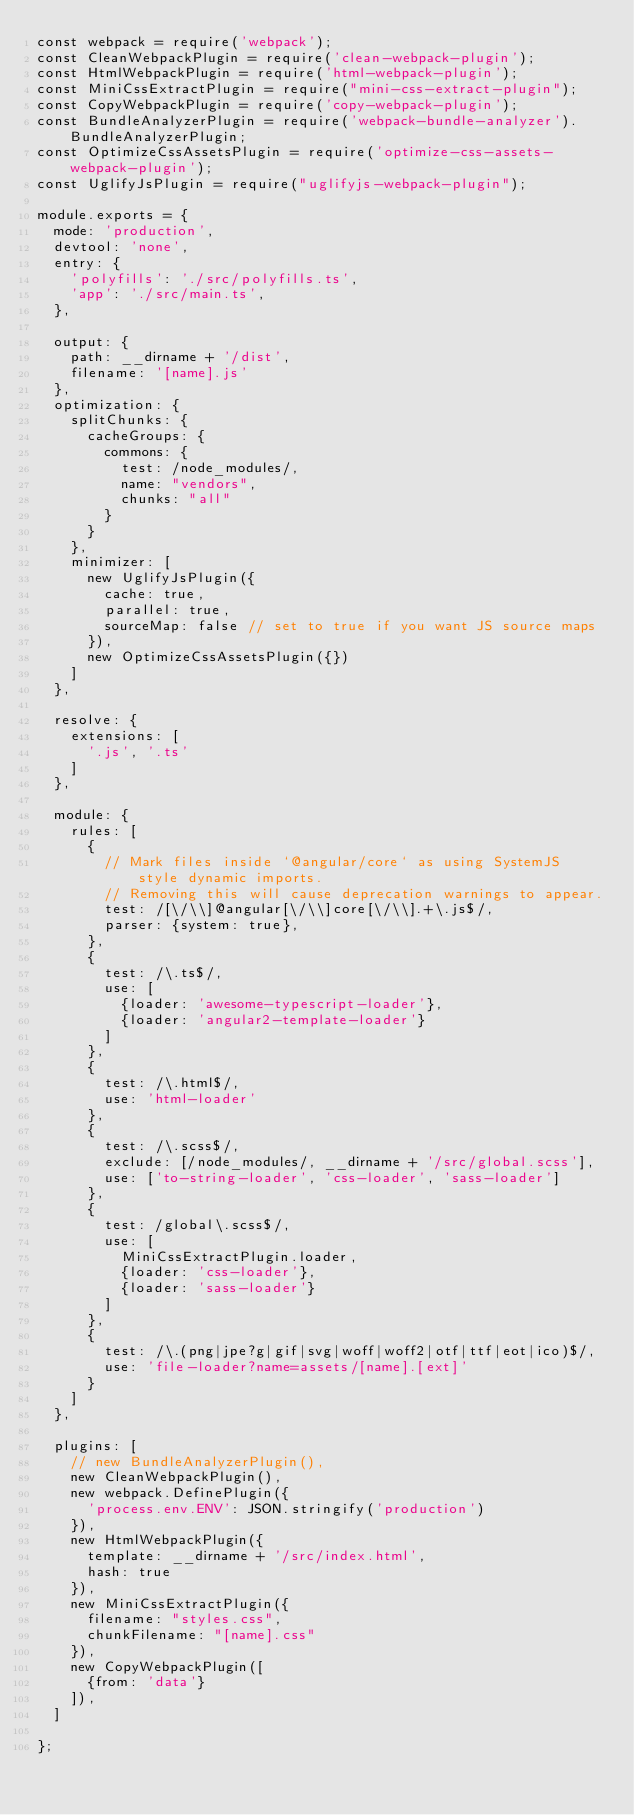Convert code to text. <code><loc_0><loc_0><loc_500><loc_500><_JavaScript_>const webpack = require('webpack');
const CleanWebpackPlugin = require('clean-webpack-plugin');
const HtmlWebpackPlugin = require('html-webpack-plugin');
const MiniCssExtractPlugin = require("mini-css-extract-plugin");
const CopyWebpackPlugin = require('copy-webpack-plugin');
const BundleAnalyzerPlugin = require('webpack-bundle-analyzer').BundleAnalyzerPlugin;
const OptimizeCssAssetsPlugin = require('optimize-css-assets-webpack-plugin');
const UglifyJsPlugin = require("uglifyjs-webpack-plugin");

module.exports = {
  mode: 'production',
  devtool: 'none',
  entry: {
    'polyfills': './src/polyfills.ts',
    'app': './src/main.ts',
  },

  output: {
    path: __dirname + '/dist',
    filename: '[name].js'
  },
  optimization: {
    splitChunks: {
      cacheGroups: {
        commons: {
          test: /node_modules/,
          name: "vendors",
          chunks: "all"
        }
      }
    },
    minimizer: [
      new UglifyJsPlugin({
        cache: true,
        parallel: true,
        sourceMap: false // set to true if you want JS source maps
      }),
      new OptimizeCssAssetsPlugin({})
    ]
  },

  resolve: {
    extensions: [
      '.js', '.ts'
    ]
  },

  module: {
    rules: [
      {
        // Mark files inside `@angular/core` as using SystemJS style dynamic imports.
        // Removing this will cause deprecation warnings to appear.
        test: /[\/\\]@angular[\/\\]core[\/\\].+\.js$/,
        parser: {system: true},
      },
      {
        test: /\.ts$/,
        use: [
          {loader: 'awesome-typescript-loader'},
          {loader: 'angular2-template-loader'}
        ]
      },
      {
        test: /\.html$/,
        use: 'html-loader'
      },
      {
        test: /\.scss$/,
        exclude: [/node_modules/, __dirname + '/src/global.scss'],
        use: ['to-string-loader', 'css-loader', 'sass-loader']
      },
      {
        test: /global\.scss$/,
        use: [
          MiniCssExtractPlugin.loader,
          {loader: 'css-loader'},
          {loader: 'sass-loader'}
        ]
      },
      {
        test: /\.(png|jpe?g|gif|svg|woff|woff2|otf|ttf|eot|ico)$/,
        use: 'file-loader?name=assets/[name].[ext]'
      }
    ]
  },

  plugins: [
    // new BundleAnalyzerPlugin(),
    new CleanWebpackPlugin(),
    new webpack.DefinePlugin({
      'process.env.ENV': JSON.stringify('production')
    }),
    new HtmlWebpackPlugin({
      template: __dirname + '/src/index.html',
      hash: true
    }),
    new MiniCssExtractPlugin({
      filename: "styles.css",
      chunkFilename: "[name].css"
    }),
    new CopyWebpackPlugin([
      {from: 'data'}
    ]),
  ]

};
</code> 